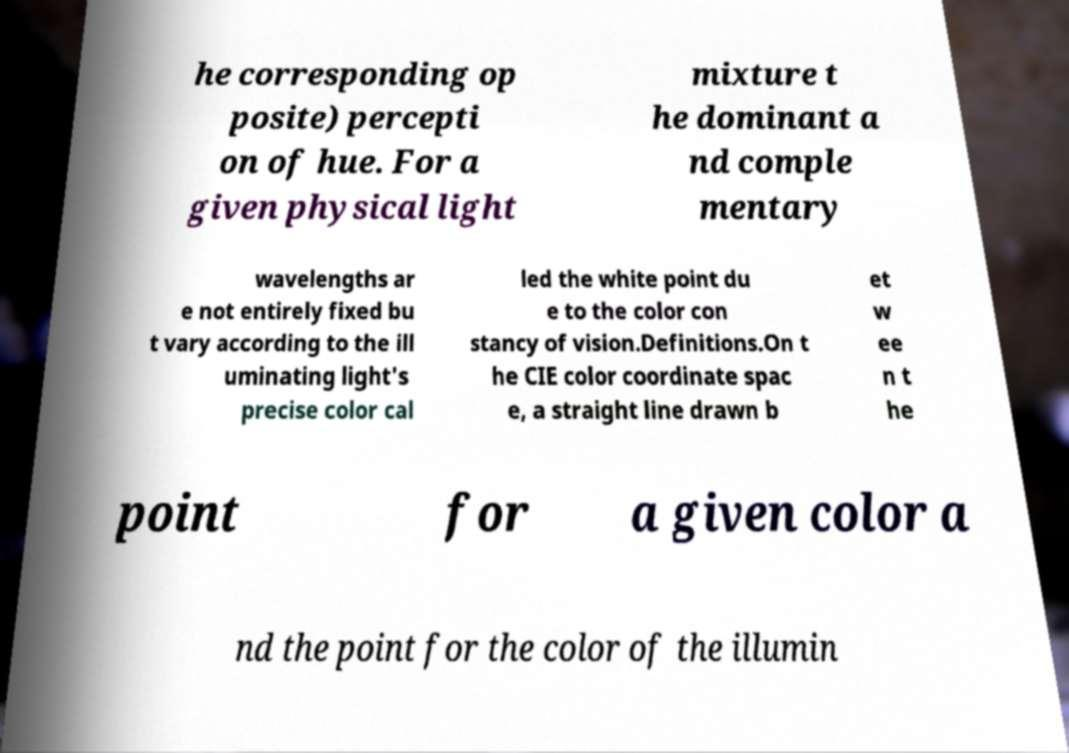There's text embedded in this image that I need extracted. Can you transcribe it verbatim? he corresponding op posite) percepti on of hue. For a given physical light mixture t he dominant a nd comple mentary wavelengths ar e not entirely fixed bu t vary according to the ill uminating light's precise color cal led the white point du e to the color con stancy of vision.Definitions.On t he CIE color coordinate spac e, a straight line drawn b et w ee n t he point for a given color a nd the point for the color of the illumin 